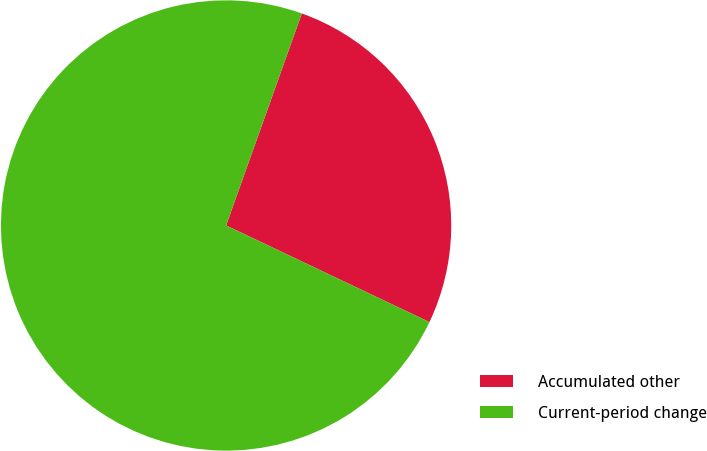<chart> <loc_0><loc_0><loc_500><loc_500><pie_chart><fcel>Accumulated other<fcel>Current-period change<nl><fcel>26.6%<fcel>73.4%<nl></chart> 